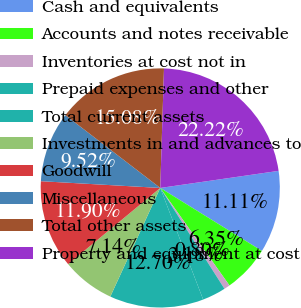Convert chart to OTSL. <chart><loc_0><loc_0><loc_500><loc_500><pie_chart><fcel>Cash and equivalents<fcel>Accounts and notes receivable<fcel>Inventories at cost not in<fcel>Prepaid expenses and other<fcel>Total current assets<fcel>Investments in and advances to<fcel>Goodwill<fcel>Miscellaneous<fcel>Total other assets<fcel>Property and equipment at cost<nl><fcel>11.11%<fcel>6.35%<fcel>0.8%<fcel>3.18%<fcel>12.7%<fcel>7.14%<fcel>11.9%<fcel>9.52%<fcel>15.08%<fcel>22.22%<nl></chart> 